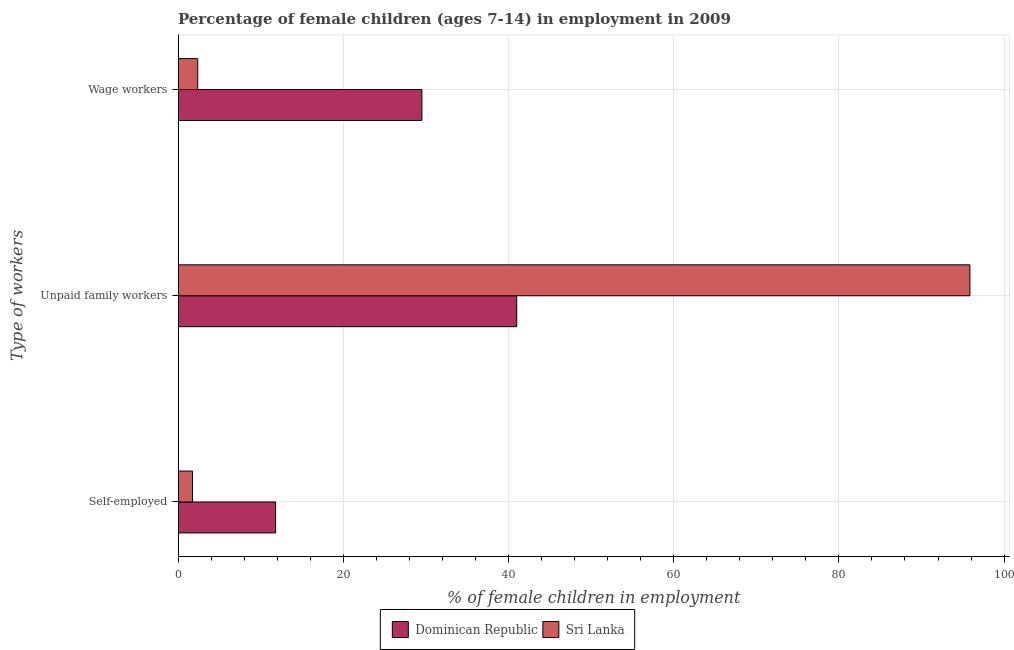How many groups of bars are there?
Your answer should be very brief. 3. Are the number of bars per tick equal to the number of legend labels?
Offer a terse response. Yes. What is the label of the 3rd group of bars from the top?
Ensure brevity in your answer.  Self-employed. What is the percentage of children employed as unpaid family workers in Sri Lanka?
Your answer should be very brief. 95.86. Across all countries, what is the maximum percentage of children employed as unpaid family workers?
Provide a succinct answer. 95.86. Across all countries, what is the minimum percentage of children employed as unpaid family workers?
Provide a succinct answer. 41. In which country was the percentage of children employed as unpaid family workers maximum?
Keep it short and to the point. Sri Lanka. In which country was the percentage of self employed children minimum?
Offer a terse response. Sri Lanka. What is the total percentage of children employed as wage workers in the graph?
Offer a terse response. 31.9. What is the difference between the percentage of children employed as unpaid family workers in Sri Lanka and that in Dominican Republic?
Provide a succinct answer. 54.86. What is the difference between the percentage of children employed as wage workers in Dominican Republic and the percentage of children employed as unpaid family workers in Sri Lanka?
Give a very brief answer. -66.34. What is the average percentage of children employed as wage workers per country?
Ensure brevity in your answer.  15.95. What is the difference between the percentage of children employed as unpaid family workers and percentage of children employed as wage workers in Dominican Republic?
Offer a terse response. 11.48. In how many countries, is the percentage of children employed as wage workers greater than 32 %?
Keep it short and to the point. 0. What is the ratio of the percentage of children employed as unpaid family workers in Sri Lanka to that in Dominican Republic?
Your response must be concise. 2.34. What is the difference between the highest and the second highest percentage of children employed as wage workers?
Your answer should be very brief. 27.14. What is the difference between the highest and the lowest percentage of children employed as wage workers?
Keep it short and to the point. 27.14. Is the sum of the percentage of self employed children in Sri Lanka and Dominican Republic greater than the maximum percentage of children employed as wage workers across all countries?
Your response must be concise. No. What does the 1st bar from the top in Unpaid family workers represents?
Make the answer very short. Sri Lanka. What does the 1st bar from the bottom in Wage workers represents?
Your answer should be very brief. Dominican Republic. How many bars are there?
Keep it short and to the point. 6. Are the values on the major ticks of X-axis written in scientific E-notation?
Ensure brevity in your answer.  No. How many legend labels are there?
Your answer should be compact. 2. What is the title of the graph?
Offer a terse response. Percentage of female children (ages 7-14) in employment in 2009. Does "Finland" appear as one of the legend labels in the graph?
Give a very brief answer. No. What is the label or title of the X-axis?
Offer a very short reply. % of female children in employment. What is the label or title of the Y-axis?
Make the answer very short. Type of workers. What is the % of female children in employment of Dominican Republic in Self-employed?
Provide a short and direct response. 11.81. What is the % of female children in employment of Sri Lanka in Self-employed?
Ensure brevity in your answer.  1.75. What is the % of female children in employment in Dominican Republic in Unpaid family workers?
Your answer should be compact. 41. What is the % of female children in employment of Sri Lanka in Unpaid family workers?
Your response must be concise. 95.86. What is the % of female children in employment of Dominican Republic in Wage workers?
Make the answer very short. 29.52. What is the % of female children in employment of Sri Lanka in Wage workers?
Ensure brevity in your answer.  2.38. Across all Type of workers, what is the maximum % of female children in employment in Sri Lanka?
Offer a terse response. 95.86. Across all Type of workers, what is the minimum % of female children in employment of Dominican Republic?
Provide a succinct answer. 11.81. Across all Type of workers, what is the minimum % of female children in employment in Sri Lanka?
Your answer should be compact. 1.75. What is the total % of female children in employment of Dominican Republic in the graph?
Give a very brief answer. 82.33. What is the total % of female children in employment in Sri Lanka in the graph?
Your response must be concise. 99.99. What is the difference between the % of female children in employment of Dominican Republic in Self-employed and that in Unpaid family workers?
Your answer should be compact. -29.19. What is the difference between the % of female children in employment of Sri Lanka in Self-employed and that in Unpaid family workers?
Ensure brevity in your answer.  -94.11. What is the difference between the % of female children in employment in Dominican Republic in Self-employed and that in Wage workers?
Provide a succinct answer. -17.71. What is the difference between the % of female children in employment of Sri Lanka in Self-employed and that in Wage workers?
Give a very brief answer. -0.63. What is the difference between the % of female children in employment of Dominican Republic in Unpaid family workers and that in Wage workers?
Provide a succinct answer. 11.48. What is the difference between the % of female children in employment of Sri Lanka in Unpaid family workers and that in Wage workers?
Make the answer very short. 93.48. What is the difference between the % of female children in employment of Dominican Republic in Self-employed and the % of female children in employment of Sri Lanka in Unpaid family workers?
Your response must be concise. -84.05. What is the difference between the % of female children in employment of Dominican Republic in Self-employed and the % of female children in employment of Sri Lanka in Wage workers?
Give a very brief answer. 9.43. What is the difference between the % of female children in employment in Dominican Republic in Unpaid family workers and the % of female children in employment in Sri Lanka in Wage workers?
Make the answer very short. 38.62. What is the average % of female children in employment of Dominican Republic per Type of workers?
Make the answer very short. 27.44. What is the average % of female children in employment of Sri Lanka per Type of workers?
Offer a very short reply. 33.33. What is the difference between the % of female children in employment in Dominican Republic and % of female children in employment in Sri Lanka in Self-employed?
Provide a short and direct response. 10.06. What is the difference between the % of female children in employment of Dominican Republic and % of female children in employment of Sri Lanka in Unpaid family workers?
Your answer should be very brief. -54.86. What is the difference between the % of female children in employment of Dominican Republic and % of female children in employment of Sri Lanka in Wage workers?
Your response must be concise. 27.14. What is the ratio of the % of female children in employment of Dominican Republic in Self-employed to that in Unpaid family workers?
Keep it short and to the point. 0.29. What is the ratio of the % of female children in employment in Sri Lanka in Self-employed to that in Unpaid family workers?
Provide a short and direct response. 0.02. What is the ratio of the % of female children in employment of Dominican Republic in Self-employed to that in Wage workers?
Ensure brevity in your answer.  0.4. What is the ratio of the % of female children in employment of Sri Lanka in Self-employed to that in Wage workers?
Your answer should be compact. 0.74. What is the ratio of the % of female children in employment of Dominican Republic in Unpaid family workers to that in Wage workers?
Provide a succinct answer. 1.39. What is the ratio of the % of female children in employment in Sri Lanka in Unpaid family workers to that in Wage workers?
Offer a very short reply. 40.28. What is the difference between the highest and the second highest % of female children in employment of Dominican Republic?
Your response must be concise. 11.48. What is the difference between the highest and the second highest % of female children in employment in Sri Lanka?
Provide a succinct answer. 93.48. What is the difference between the highest and the lowest % of female children in employment in Dominican Republic?
Ensure brevity in your answer.  29.19. What is the difference between the highest and the lowest % of female children in employment in Sri Lanka?
Give a very brief answer. 94.11. 